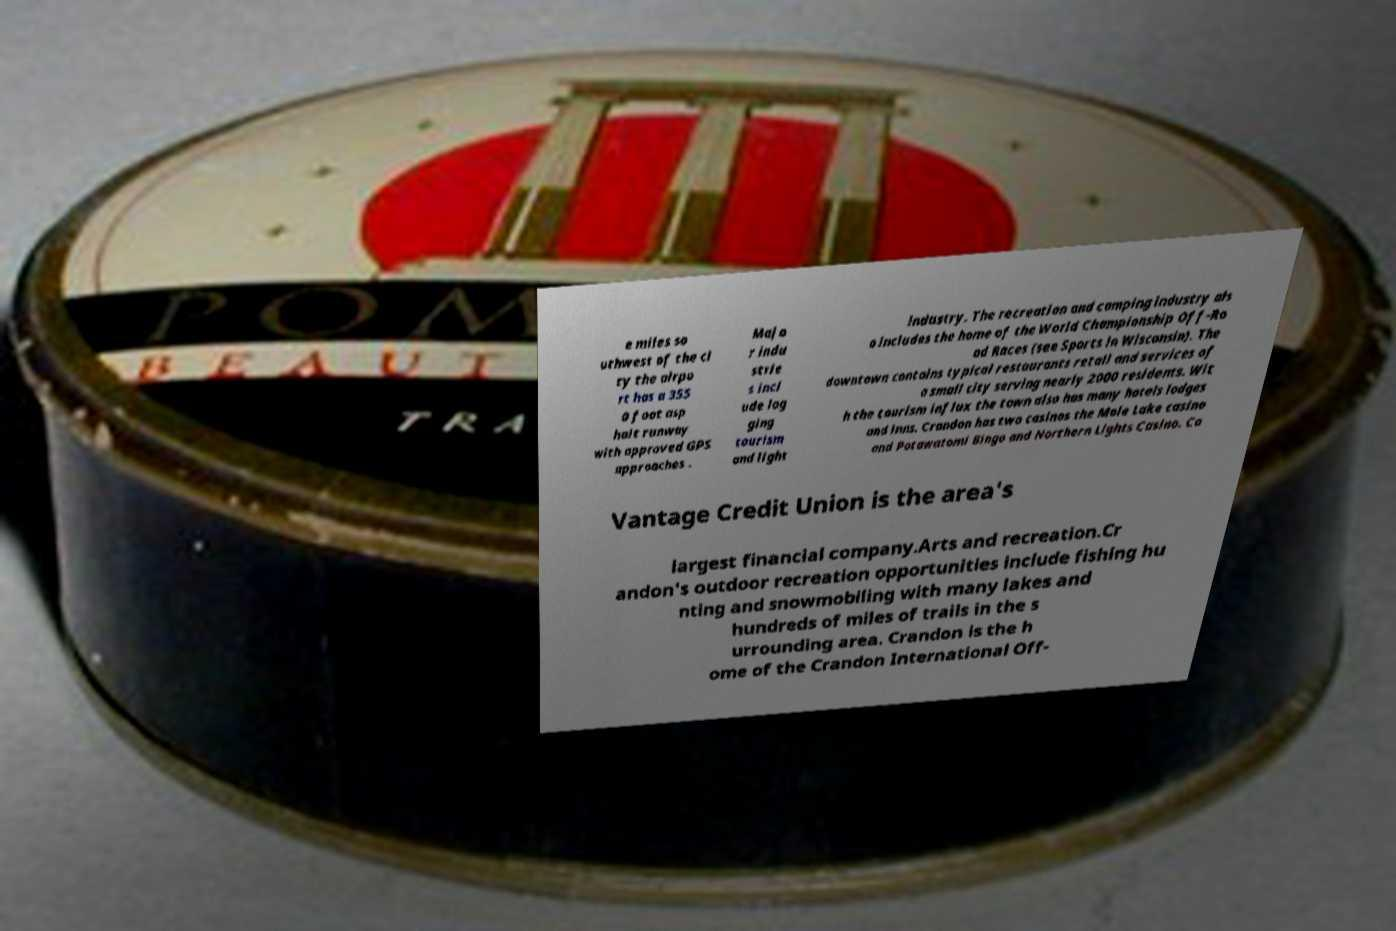Can you read and provide the text displayed in the image?This photo seems to have some interesting text. Can you extract and type it out for me? e miles so uthwest of the ci ty the airpo rt has a 355 0 foot asp halt runway with approved GPS approaches . Majo r indu strie s incl ude log ging tourism and light industry. The recreation and camping industry als o includes the home of the World Championship Off-Ro ad Races (see Sports in Wisconsin). The downtown contains typical restaurants retail and services of a small city serving nearly 2000 residents. Wit h the tourism influx the town also has many hotels lodges and inns. Crandon has two casinos the Mole Lake casino and Potawatomi Bingo and Northern Lights Casino. Co Vantage Credit Union is the area's largest financial company.Arts and recreation.Cr andon's outdoor recreation opportunities include fishing hu nting and snowmobiling with many lakes and hundreds of miles of trails in the s urrounding area. Crandon is the h ome of the Crandon International Off- 